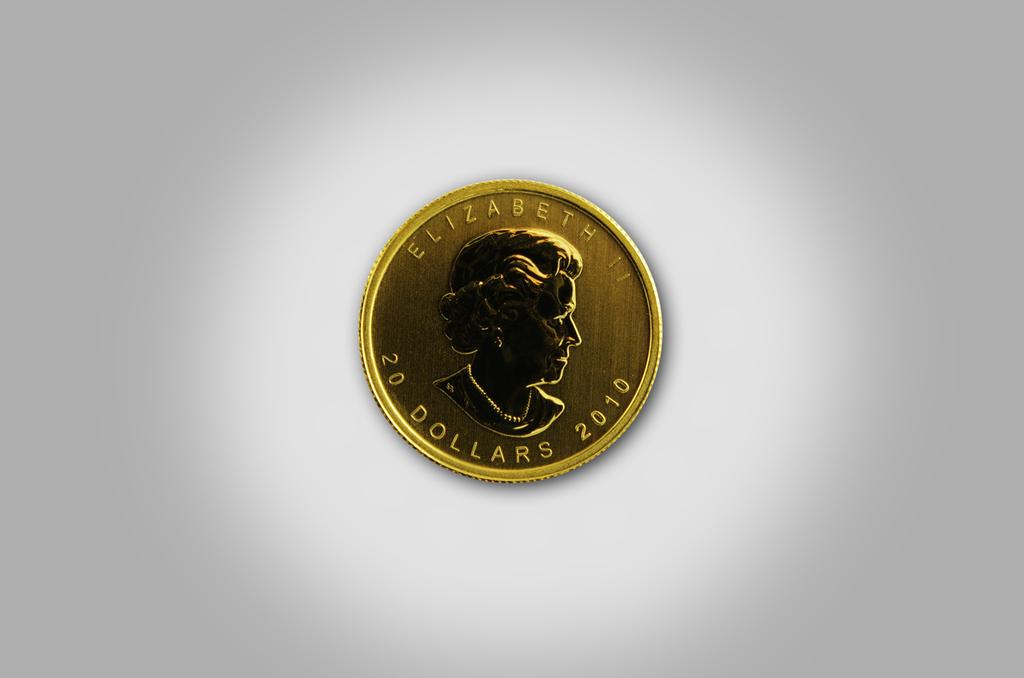How much is this coin worth?
Offer a very short reply. 20 dollars. What queen is shown on the gold coin?
Offer a very short reply. Elizabeth. 